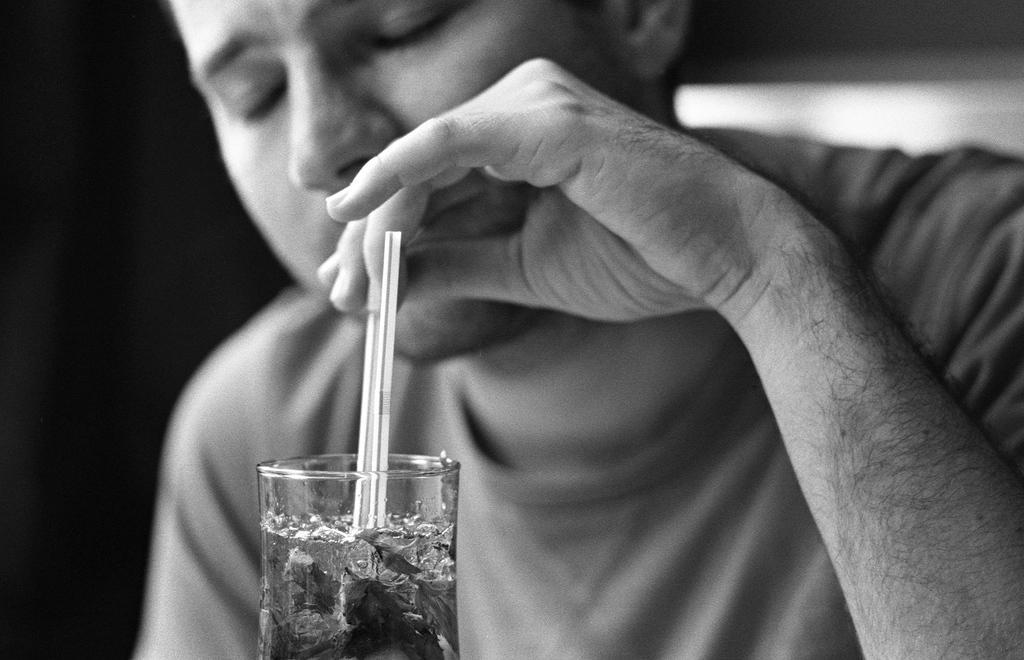Describe this image in one or two sentences. In this image we can see a person is holding something in his hands and keeping it in a glass. 